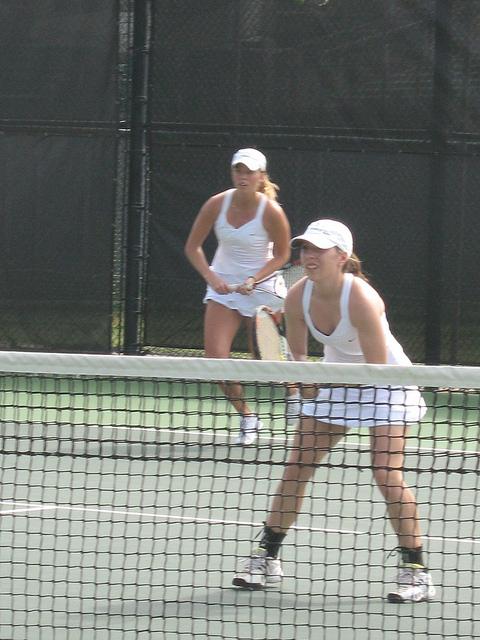Are these professional players?
Short answer required. No. Are the women's socks are the same color as her hat?
Short answer required. No. What are the women doing?
Answer briefly. Playing tennis. Are the players twins?
Quick response, please. No. What color is the shirt?
Concise answer only. White. How many of these players are swinging?
Answer briefly. 0. 